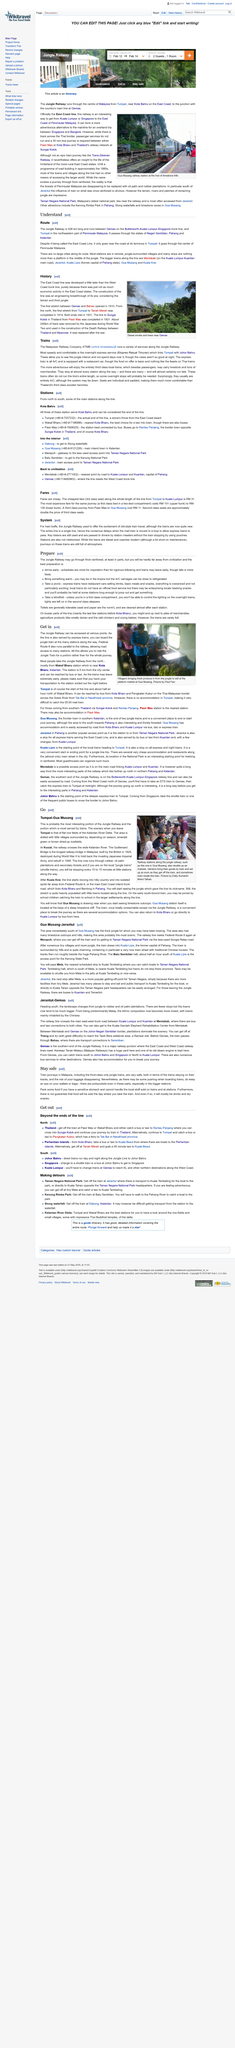Draw attention to some important aspects in this diagram. The most speedy and comfortable train is the overnight express service (Ekspres Raykat Timuran), which provides a comfortable and efficient travel experience for passengers. The Jungle Railway, according to "Route", is a distance of 526 km long. Third class local trains carry not only passengers but also livestock and a significant amount of merchandise, which further highlights their versatility in transporting various goods and commodities. The seats in third class local trains are padded and individual, providing a comfortable and spacious seating experience for passengers. The Jungle Railway route does not pass through any large cities. 